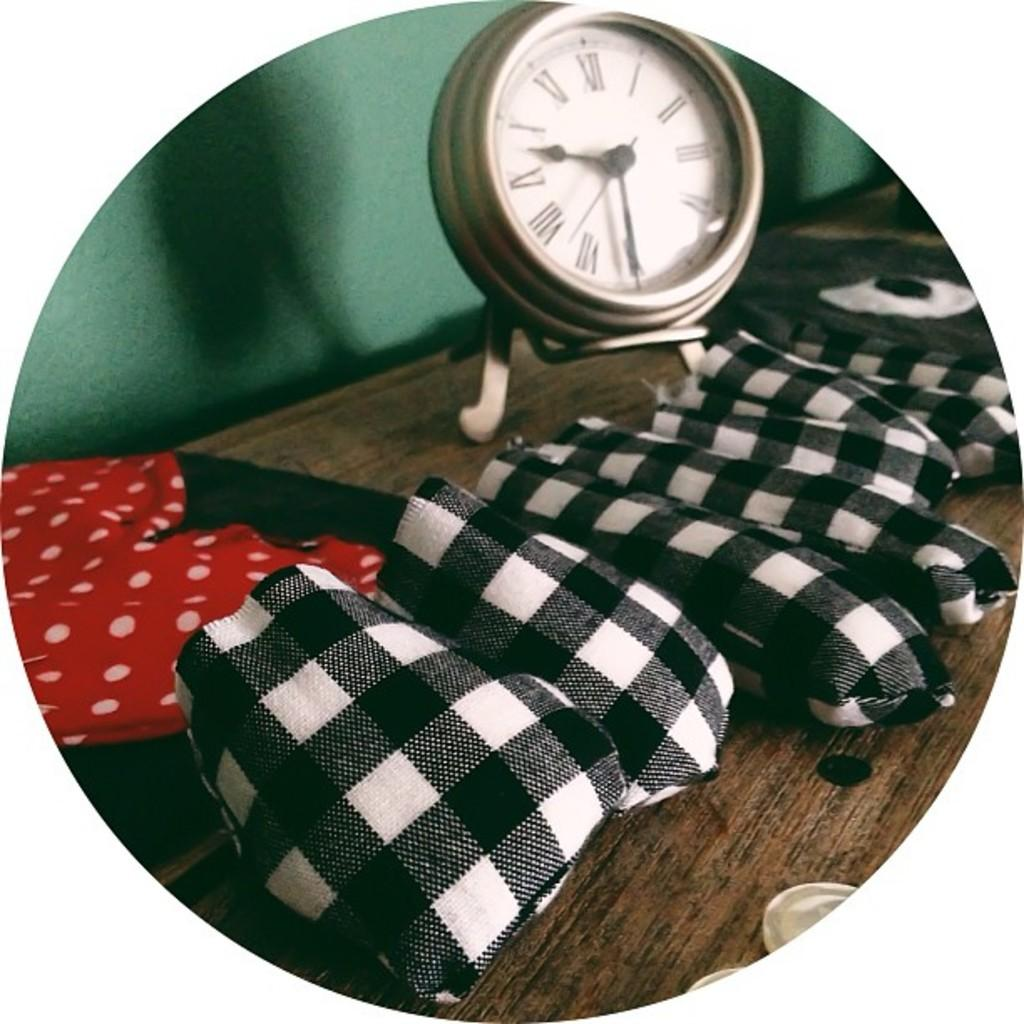<image>
Render a clear and concise summary of the photo. An analog clock with roman numerals I through XII. 